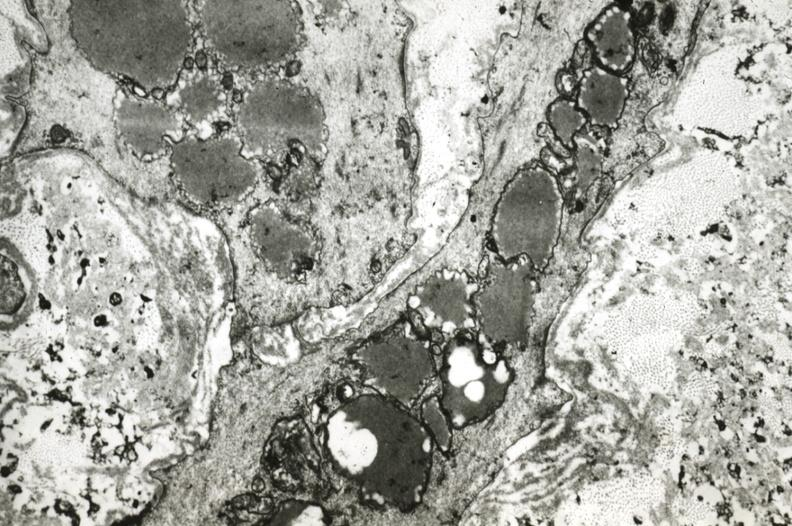s vasculature present?
Answer the question using a single word or phrase. Yes 